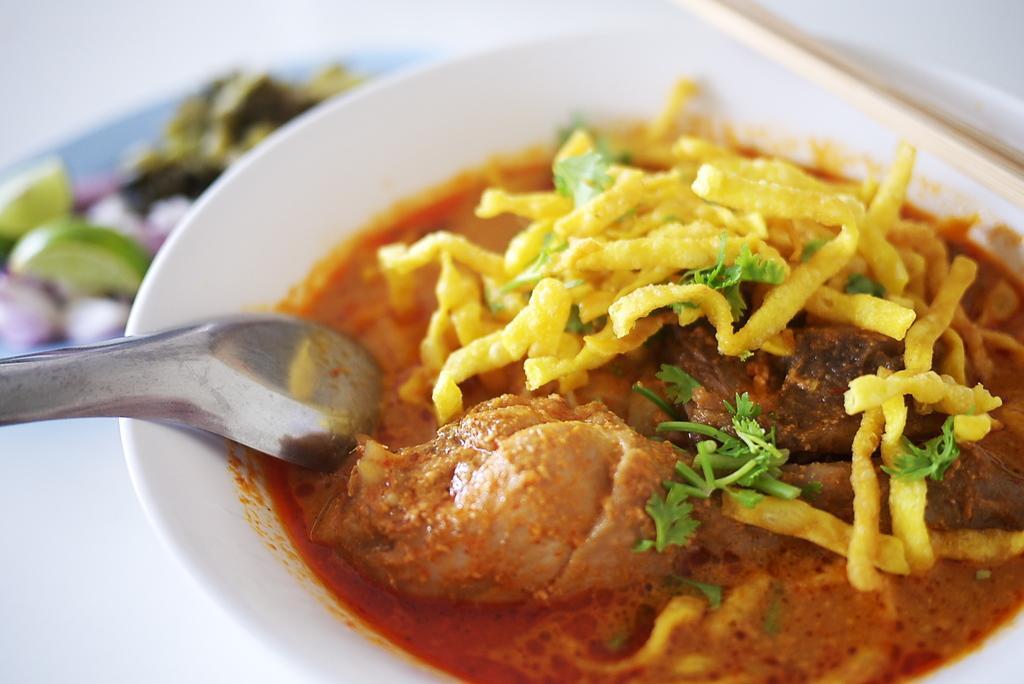Can you describe this image briefly? In this image in front there are food items in a bowl and there is a spoon. Beside the bowl there are food items placed on a table. 